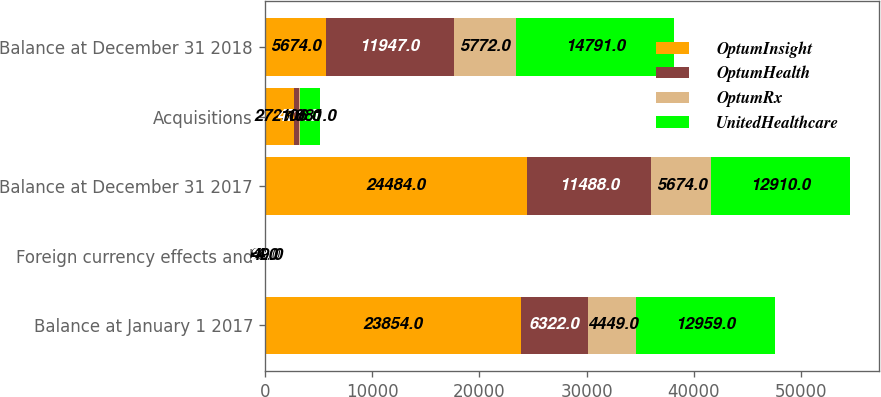Convert chart. <chart><loc_0><loc_0><loc_500><loc_500><stacked_bar_chart><ecel><fcel>Balance at January 1 2017<fcel>Foreign currency effects and<fcel>Balance at December 31 2017<fcel>Acquisitions<fcel>Balance at December 31 2018<nl><fcel>OptumInsight<fcel>23854<fcel>60<fcel>24484<fcel>2723<fcel>5674<nl><fcel>OptumHealth<fcel>6322<fcel>23<fcel>11488<fcel>471<fcel>11947<nl><fcel>OptumRx<fcel>4449<fcel>4<fcel>5674<fcel>106<fcel>5772<nl><fcel>UnitedHealthcare<fcel>12959<fcel>49<fcel>12910<fcel>1881<fcel>14791<nl></chart> 